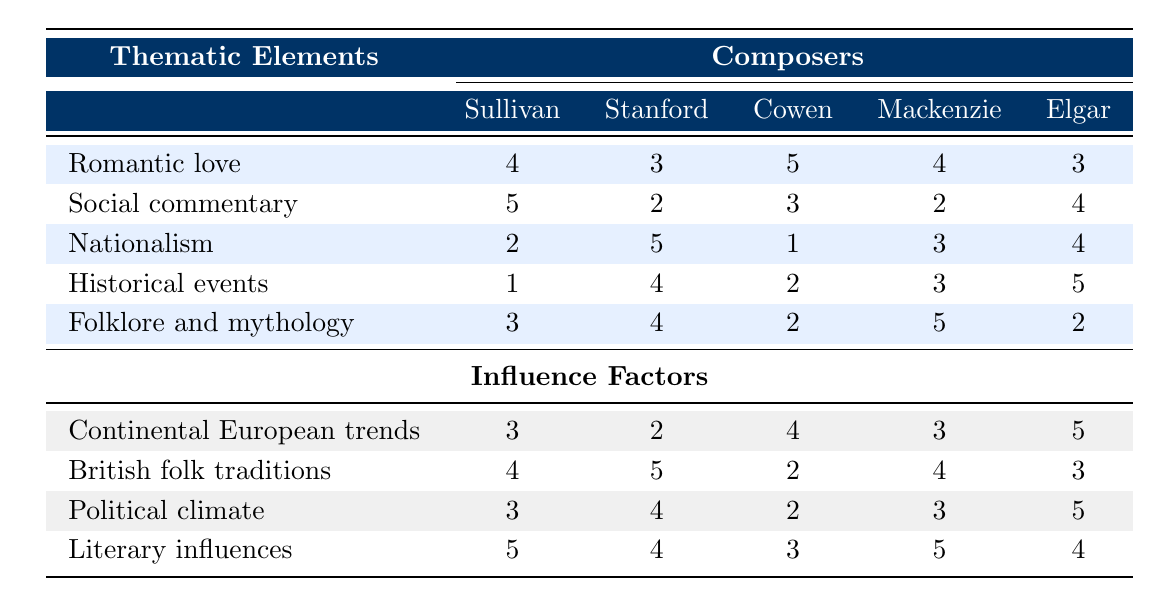What is the thematic element with the highest score in Arthur Sullivan's opera "The Gondoliers"? The scores for each thematic element in "The Gondoliers" by Arthur Sullivan are: Romantic love (4), Social commentary (5), Nationalism (2), Historical events (1), Folklore and mythology (3). The highest score is for Social commentary with a score of 5.
Answer: 5 Which composer has the lowest score for Nationalism? Looking at the Nationalism scores, Arthur Sullivan has a score of 2, Charles Villiers Stanford has a score of 5, Frederic Hymen Cowen has a score of 1, Alexander Mackenzie has a score of 3, and Edward Elgar has a score of 4. Frederic Hymen Cowen has the lowest score of 1.
Answer: 1 What is the sum of the Romantic love scores across all composers? The Romantic love scores are: Sullivan (4), Stanford (3), Cowen (5), Mackenzie (4), Elgar (3). Adding these together: 4 + 3 + 5 + 4 + 3 = 19.
Answer: 19 Does Edward Elgar have a higher score in Historical events compared to Charles Villiers Stanford? Edward Elgar's score for Historical events is 5, while Charles Villiers Stanford's score is 4. Since 5 is greater than 4, Edward Elgar does have a higher score.
Answer: Yes What is the average score for Folklore and mythology among all composers? The scores for Folklore and mythology are: Sullivan (3), Stanford (4), Cowen (2), Mackenzie (5), Elgar (2). The average score is calculated as follows: (3 + 4 + 2 + 5 + 2) / 5 = 16 / 5 = 3.2.
Answer: 3.2 Which influence factor has the highest score for Elgar? Checking the influence factors for Elgar: Continental European trends (5), British folk traditions (3), Political climate (5), Literary influences (4). Both Continental European trends and Political climate have the highest score of 5.
Answer: 5 Which thematic element does Alexander Mackenzie score the highest? Alexander Mackenzie's scores for thematic elements are: Romantic love (4), Social commentary (2), Nationalism (3), Historical events (3), Folklore and mythology (5). His highest score is for Folklore and mythology with a score of 5.
Answer: 5 How many composers scored a 4 for Social commentary? The composers' scores for Social commentary are: Sullivan (5), Stanford (2), Cowen (3), Mackenzie (2), Elgar (4). Only Edward Elgar scored a 4 for Social commentary.
Answer: 1 